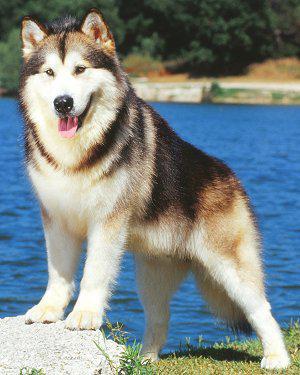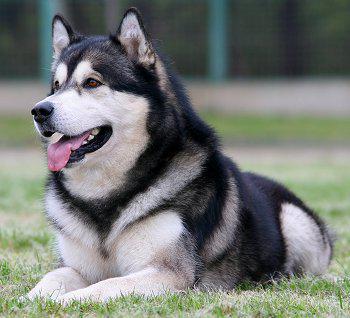The first image is the image on the left, the second image is the image on the right. For the images shown, is this caption "The right image contains one dog attached to a leash." true? Answer yes or no. No. The first image is the image on the left, the second image is the image on the right. For the images shown, is this caption "Each image shows a husky standing on all fours, and the dog on the right wears a leash." true? Answer yes or no. No. 